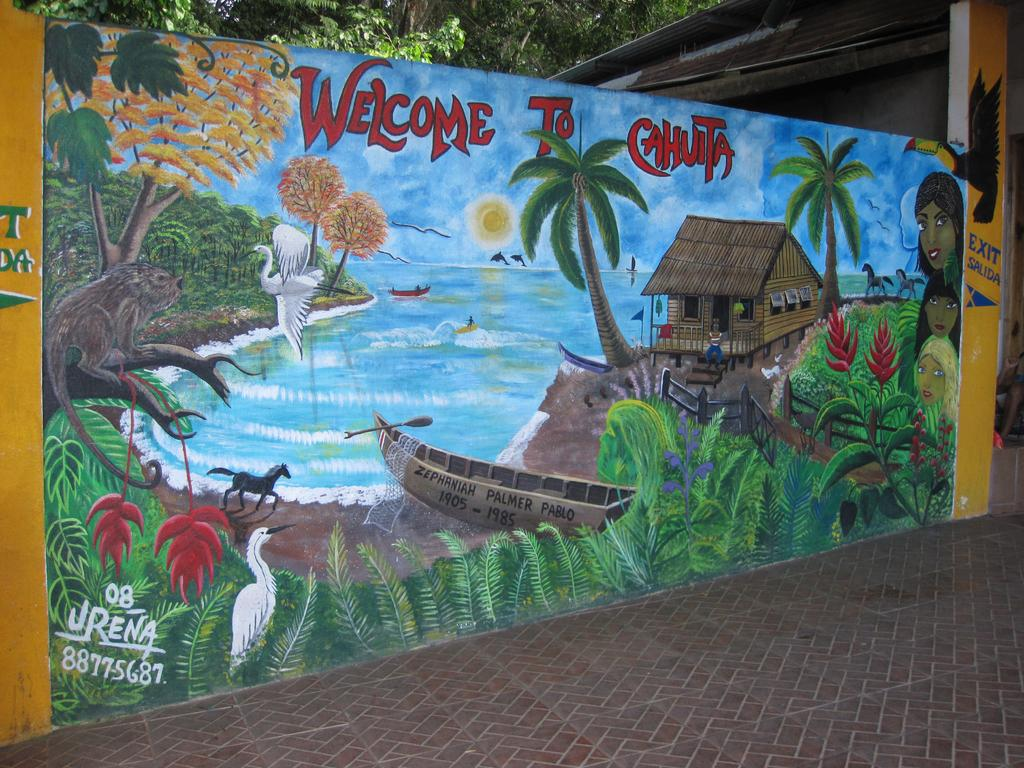What is featured on the banner in the image? The banner contains a painting. What elements are included in the painting? The painting includes plants, a boat, water, a horse, trees, a sky, and clouds. What type of structure is visible in the painting? The painting includes a house. What natural elements are visible in the image outside of the painting? There are trees visible in the image. How many snakes can be seen slithering through the wilderness in the image? There are no snakes or wilderness present in the image; it features a banner with a painting that includes various elements, such as a boat, water, and a house. 